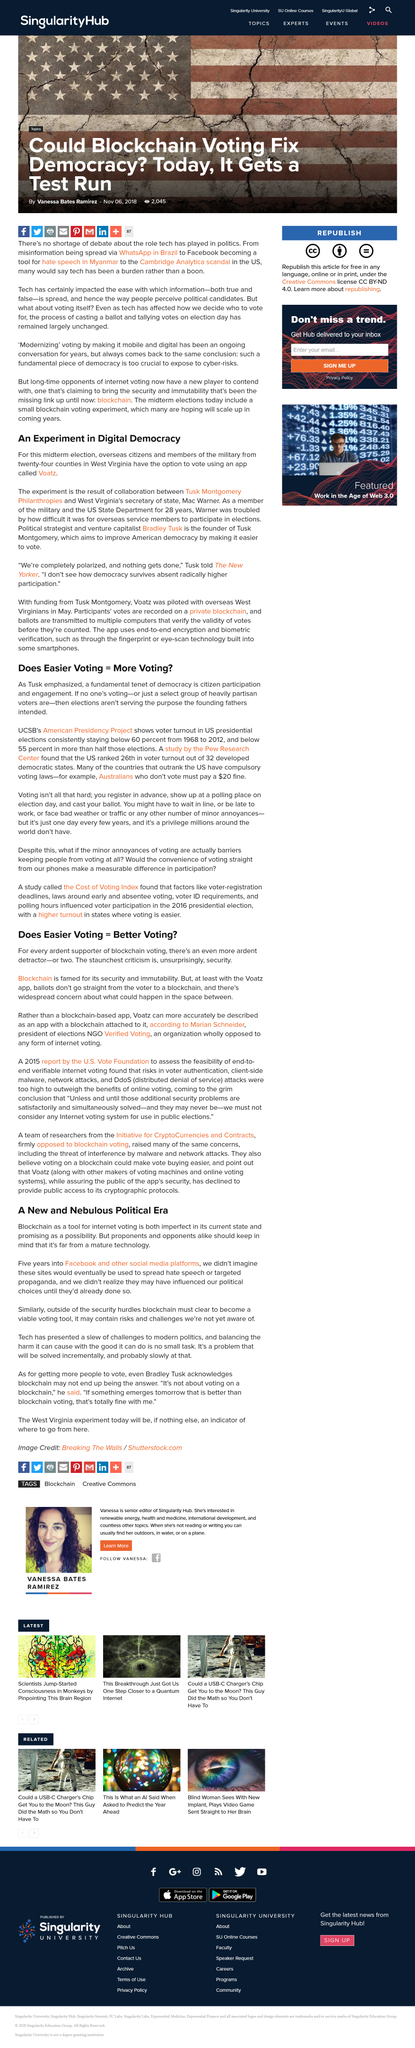Give some essential details in this illustration. The American Presidency Project at UCSB revealed that voter turnout in US presidential elections has consistently remained below 60 percent from 1968 to 2012, with over half of those elections registering a voter turnout below 55 percent. The use of Blockchain as a tool for Internet voting has been proposed as a solution to ensure the integrity and security of the voting process. Bradley Tusk is the founder of Tusk Montgomery. Blockchain voting is both celebrated for its security and condemned for its perceived lack of security. Tusk Montgomery aims to improve American democracy by making it easier to vote and experimenting in digital democracy. 